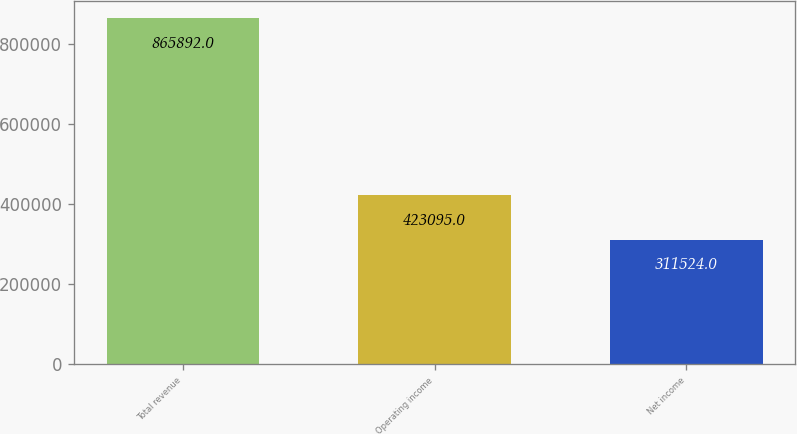Convert chart. <chart><loc_0><loc_0><loc_500><loc_500><bar_chart><fcel>Total revenue<fcel>Operating income<fcel>Net income<nl><fcel>865892<fcel>423095<fcel>311524<nl></chart> 